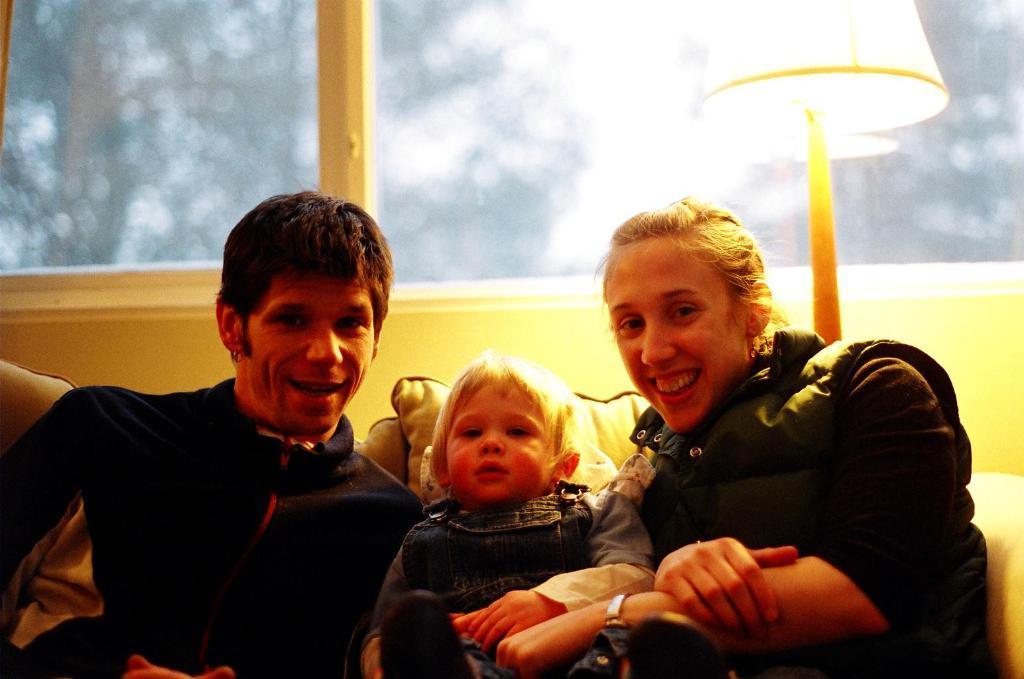In one or two sentences, can you explain what this image depicts? In this image I can see a man, a boy, and a woman. Behind them I can see few cushions and a lamp. I can also see this image is little bit blurry in the background and in the front I can see all of them are wearing jackets and except one I can see smile on two faces. 